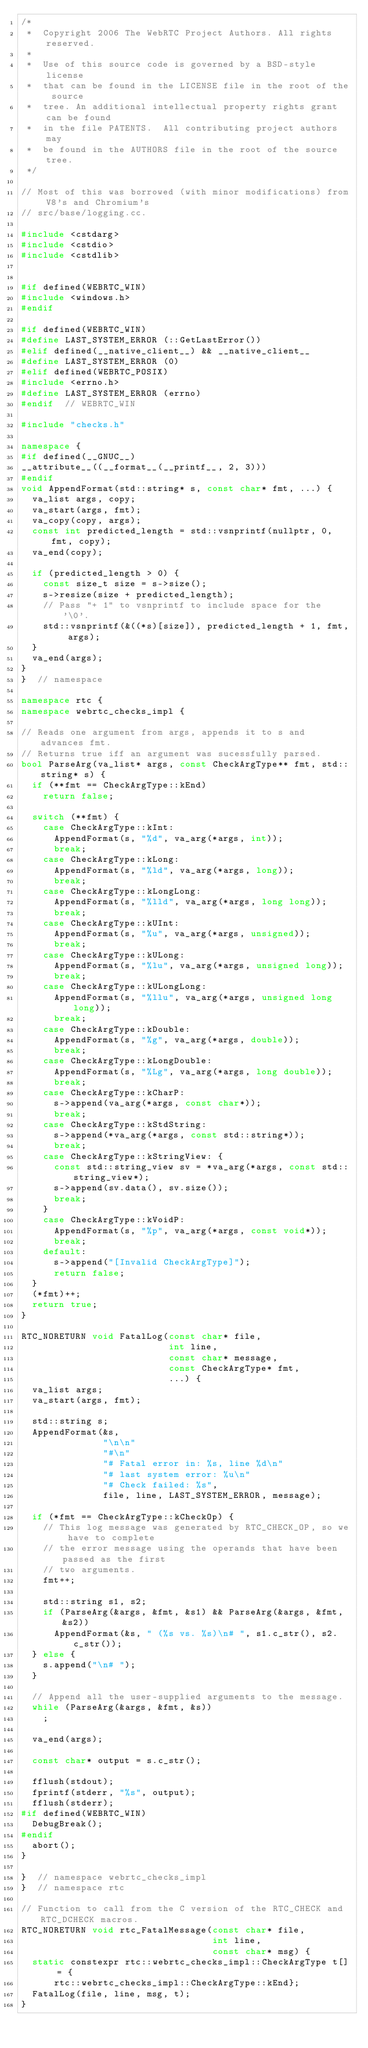Convert code to text. <code><loc_0><loc_0><loc_500><loc_500><_C++_>/*
 *  Copyright 2006 The WebRTC Project Authors. All rights reserved.
 *
 *  Use of this source code is governed by a BSD-style license
 *  that can be found in the LICENSE file in the root of the source
 *  tree. An additional intellectual property rights grant can be found
 *  in the file PATENTS.  All contributing project authors may
 *  be found in the AUTHORS file in the root of the source tree.
 */

// Most of this was borrowed (with minor modifications) from V8's and Chromium's
// src/base/logging.cc.

#include <cstdarg>
#include <cstdio>
#include <cstdlib>


#if defined(WEBRTC_WIN)
#include <windows.h>
#endif

#if defined(WEBRTC_WIN)
#define LAST_SYSTEM_ERROR (::GetLastError())
#elif defined(__native_client__) && __native_client__
#define LAST_SYSTEM_ERROR (0)
#elif defined(WEBRTC_POSIX)
#include <errno.h>
#define LAST_SYSTEM_ERROR (errno)
#endif  // WEBRTC_WIN

#include "checks.h"

namespace {
#if defined(__GNUC__)
__attribute__((__format__(__printf__, 2, 3)))
#endif
void AppendFormat(std::string* s, const char* fmt, ...) {
  va_list args, copy;
  va_start(args, fmt);
  va_copy(copy, args);
  const int predicted_length = std::vsnprintf(nullptr, 0, fmt, copy);
  va_end(copy);

  if (predicted_length > 0) {
    const size_t size = s->size();
    s->resize(size + predicted_length);
    // Pass "+ 1" to vsnprintf to include space for the '\0'.
    std::vsnprintf(&((*s)[size]), predicted_length + 1, fmt, args);
  }
  va_end(args);
}
}  // namespace

namespace rtc {
namespace webrtc_checks_impl {

// Reads one argument from args, appends it to s and advances fmt.
// Returns true iff an argument was sucessfully parsed.
bool ParseArg(va_list* args, const CheckArgType** fmt, std::string* s) {
  if (**fmt == CheckArgType::kEnd)
    return false;

  switch (**fmt) {
    case CheckArgType::kInt:
      AppendFormat(s, "%d", va_arg(*args, int));
      break;
    case CheckArgType::kLong:
      AppendFormat(s, "%ld", va_arg(*args, long));
      break;
    case CheckArgType::kLongLong:
      AppendFormat(s, "%lld", va_arg(*args, long long));
      break;
    case CheckArgType::kUInt:
      AppendFormat(s, "%u", va_arg(*args, unsigned));
      break;
    case CheckArgType::kULong:
      AppendFormat(s, "%lu", va_arg(*args, unsigned long));
      break;
    case CheckArgType::kULongLong:
      AppendFormat(s, "%llu", va_arg(*args, unsigned long long));
      break;
    case CheckArgType::kDouble:
      AppendFormat(s, "%g", va_arg(*args, double));
      break;
    case CheckArgType::kLongDouble:
      AppendFormat(s, "%Lg", va_arg(*args, long double));
      break;
    case CheckArgType::kCharP:
      s->append(va_arg(*args, const char*));
      break;
    case CheckArgType::kStdString:
      s->append(*va_arg(*args, const std::string*));
      break;
    case CheckArgType::kStringView: {
      const std::string_view sv = *va_arg(*args, const std::string_view*);
      s->append(sv.data(), sv.size());
      break;
    }
    case CheckArgType::kVoidP:
      AppendFormat(s, "%p", va_arg(*args, const void*));
      break;
    default:
      s->append("[Invalid CheckArgType]");
      return false;
  }
  (*fmt)++;
  return true;
}

RTC_NORETURN void FatalLog(const char* file,
                           int line,
                           const char* message,
                           const CheckArgType* fmt,
                           ...) {
  va_list args;
  va_start(args, fmt);

  std::string s;
  AppendFormat(&s,
               "\n\n"
               "#\n"
               "# Fatal error in: %s, line %d\n"
               "# last system error: %u\n"
               "# Check failed: %s",
               file, line, LAST_SYSTEM_ERROR, message);

  if (*fmt == CheckArgType::kCheckOp) {
    // This log message was generated by RTC_CHECK_OP, so we have to complete
    // the error message using the operands that have been passed as the first
    // two arguments.
    fmt++;

    std::string s1, s2;
    if (ParseArg(&args, &fmt, &s1) && ParseArg(&args, &fmt, &s2))
      AppendFormat(&s, " (%s vs. %s)\n# ", s1.c_str(), s2.c_str());
  } else {
    s.append("\n# ");
  }

  // Append all the user-supplied arguments to the message.
  while (ParseArg(&args, &fmt, &s))
    ;

  va_end(args);

  const char* output = s.c_str();

  fflush(stdout);
  fprintf(stderr, "%s", output);
  fflush(stderr);
#if defined(WEBRTC_WIN)
  DebugBreak();
#endif
  abort();
}

}  // namespace webrtc_checks_impl
}  // namespace rtc

// Function to call from the C version of the RTC_CHECK and RTC_DCHECK macros.
RTC_NORETURN void rtc_FatalMessage(const char* file,
                                   int line,
                                   const char* msg) {
  static constexpr rtc::webrtc_checks_impl::CheckArgType t[] = {
      rtc::webrtc_checks_impl::CheckArgType::kEnd};
  FatalLog(file, line, msg, t);
}
</code> 